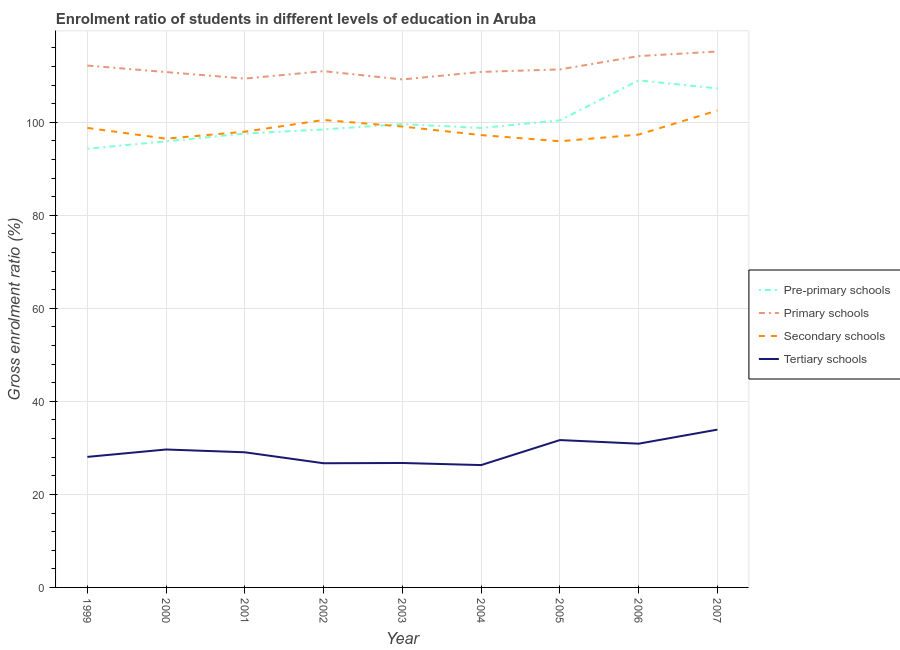How many different coloured lines are there?
Keep it short and to the point. 4. What is the gross enrolment ratio in pre-primary schools in 2001?
Your answer should be compact. 97.58. Across all years, what is the maximum gross enrolment ratio in pre-primary schools?
Your response must be concise. 109.02. Across all years, what is the minimum gross enrolment ratio in tertiary schools?
Keep it short and to the point. 26.3. What is the total gross enrolment ratio in pre-primary schools in the graph?
Keep it short and to the point. 901.43. What is the difference between the gross enrolment ratio in tertiary schools in 2003 and that in 2005?
Ensure brevity in your answer.  -4.93. What is the difference between the gross enrolment ratio in tertiary schools in 2000 and the gross enrolment ratio in primary schools in 2001?
Your answer should be compact. -79.75. What is the average gross enrolment ratio in primary schools per year?
Keep it short and to the point. 111.59. In the year 2000, what is the difference between the gross enrolment ratio in primary schools and gross enrolment ratio in secondary schools?
Offer a terse response. 14.32. In how many years, is the gross enrolment ratio in secondary schools greater than 80 %?
Make the answer very short. 9. What is the ratio of the gross enrolment ratio in secondary schools in 2001 to that in 2005?
Your response must be concise. 1.02. What is the difference between the highest and the second highest gross enrolment ratio in tertiary schools?
Your response must be concise. 2.24. What is the difference between the highest and the lowest gross enrolment ratio in pre-primary schools?
Make the answer very short. 14.69. Is the sum of the gross enrolment ratio in primary schools in 2000 and 2007 greater than the maximum gross enrolment ratio in secondary schools across all years?
Your answer should be compact. Yes. Is it the case that in every year, the sum of the gross enrolment ratio in tertiary schools and gross enrolment ratio in pre-primary schools is greater than the sum of gross enrolment ratio in secondary schools and gross enrolment ratio in primary schools?
Make the answer very short. No. Does the gross enrolment ratio in primary schools monotonically increase over the years?
Your answer should be compact. No. Is the gross enrolment ratio in pre-primary schools strictly greater than the gross enrolment ratio in secondary schools over the years?
Give a very brief answer. No. How are the legend labels stacked?
Make the answer very short. Vertical. What is the title of the graph?
Offer a terse response. Enrolment ratio of students in different levels of education in Aruba. What is the Gross enrolment ratio (%) of Pre-primary schools in 1999?
Give a very brief answer. 94.33. What is the Gross enrolment ratio (%) of Primary schools in 1999?
Provide a succinct answer. 112.2. What is the Gross enrolment ratio (%) in Secondary schools in 1999?
Give a very brief answer. 98.8. What is the Gross enrolment ratio (%) of Tertiary schools in 1999?
Keep it short and to the point. 28.07. What is the Gross enrolment ratio (%) in Pre-primary schools in 2000?
Keep it short and to the point. 95.9. What is the Gross enrolment ratio (%) of Primary schools in 2000?
Your answer should be very brief. 110.8. What is the Gross enrolment ratio (%) of Secondary schools in 2000?
Your answer should be compact. 96.49. What is the Gross enrolment ratio (%) of Tertiary schools in 2000?
Offer a terse response. 29.66. What is the Gross enrolment ratio (%) of Pre-primary schools in 2001?
Provide a short and direct response. 97.58. What is the Gross enrolment ratio (%) in Primary schools in 2001?
Provide a succinct answer. 109.4. What is the Gross enrolment ratio (%) of Secondary schools in 2001?
Keep it short and to the point. 97.99. What is the Gross enrolment ratio (%) in Tertiary schools in 2001?
Provide a succinct answer. 29.06. What is the Gross enrolment ratio (%) of Pre-primary schools in 2002?
Offer a very short reply. 98.47. What is the Gross enrolment ratio (%) of Primary schools in 2002?
Your answer should be very brief. 111. What is the Gross enrolment ratio (%) of Secondary schools in 2002?
Give a very brief answer. 100.51. What is the Gross enrolment ratio (%) of Tertiary schools in 2002?
Provide a short and direct response. 26.7. What is the Gross enrolment ratio (%) of Pre-primary schools in 2003?
Give a very brief answer. 99.62. What is the Gross enrolment ratio (%) in Primary schools in 2003?
Keep it short and to the point. 109.21. What is the Gross enrolment ratio (%) of Secondary schools in 2003?
Offer a very short reply. 99.09. What is the Gross enrolment ratio (%) of Tertiary schools in 2003?
Your answer should be compact. 26.76. What is the Gross enrolment ratio (%) of Pre-primary schools in 2004?
Offer a very short reply. 98.78. What is the Gross enrolment ratio (%) in Primary schools in 2004?
Your answer should be very brief. 110.84. What is the Gross enrolment ratio (%) in Secondary schools in 2004?
Your response must be concise. 97.25. What is the Gross enrolment ratio (%) of Tertiary schools in 2004?
Provide a succinct answer. 26.3. What is the Gross enrolment ratio (%) of Pre-primary schools in 2005?
Ensure brevity in your answer.  100.43. What is the Gross enrolment ratio (%) in Primary schools in 2005?
Ensure brevity in your answer.  111.38. What is the Gross enrolment ratio (%) in Secondary schools in 2005?
Offer a terse response. 95.93. What is the Gross enrolment ratio (%) of Tertiary schools in 2005?
Ensure brevity in your answer.  31.68. What is the Gross enrolment ratio (%) in Pre-primary schools in 2006?
Your answer should be compact. 109.02. What is the Gross enrolment ratio (%) in Primary schools in 2006?
Provide a succinct answer. 114.24. What is the Gross enrolment ratio (%) in Secondary schools in 2006?
Offer a very short reply. 97.36. What is the Gross enrolment ratio (%) in Tertiary schools in 2006?
Give a very brief answer. 30.9. What is the Gross enrolment ratio (%) in Pre-primary schools in 2007?
Give a very brief answer. 107.29. What is the Gross enrolment ratio (%) of Primary schools in 2007?
Offer a terse response. 115.22. What is the Gross enrolment ratio (%) of Secondary schools in 2007?
Offer a very short reply. 102.55. What is the Gross enrolment ratio (%) of Tertiary schools in 2007?
Keep it short and to the point. 33.93. Across all years, what is the maximum Gross enrolment ratio (%) of Pre-primary schools?
Keep it short and to the point. 109.02. Across all years, what is the maximum Gross enrolment ratio (%) of Primary schools?
Your answer should be compact. 115.22. Across all years, what is the maximum Gross enrolment ratio (%) in Secondary schools?
Give a very brief answer. 102.55. Across all years, what is the maximum Gross enrolment ratio (%) of Tertiary schools?
Make the answer very short. 33.93. Across all years, what is the minimum Gross enrolment ratio (%) in Pre-primary schools?
Your answer should be compact. 94.33. Across all years, what is the minimum Gross enrolment ratio (%) in Primary schools?
Your response must be concise. 109.21. Across all years, what is the minimum Gross enrolment ratio (%) of Secondary schools?
Make the answer very short. 95.93. Across all years, what is the minimum Gross enrolment ratio (%) of Tertiary schools?
Provide a succinct answer. 26.3. What is the total Gross enrolment ratio (%) in Pre-primary schools in the graph?
Offer a terse response. 901.43. What is the total Gross enrolment ratio (%) of Primary schools in the graph?
Provide a succinct answer. 1004.29. What is the total Gross enrolment ratio (%) in Secondary schools in the graph?
Give a very brief answer. 885.95. What is the total Gross enrolment ratio (%) in Tertiary schools in the graph?
Your response must be concise. 263.05. What is the difference between the Gross enrolment ratio (%) of Pre-primary schools in 1999 and that in 2000?
Offer a very short reply. -1.57. What is the difference between the Gross enrolment ratio (%) in Primary schools in 1999 and that in 2000?
Provide a short and direct response. 1.4. What is the difference between the Gross enrolment ratio (%) of Secondary schools in 1999 and that in 2000?
Provide a short and direct response. 2.31. What is the difference between the Gross enrolment ratio (%) in Tertiary schools in 1999 and that in 2000?
Your answer should be very brief. -1.59. What is the difference between the Gross enrolment ratio (%) of Pre-primary schools in 1999 and that in 2001?
Your response must be concise. -3.25. What is the difference between the Gross enrolment ratio (%) in Primary schools in 1999 and that in 2001?
Keep it short and to the point. 2.8. What is the difference between the Gross enrolment ratio (%) of Secondary schools in 1999 and that in 2001?
Keep it short and to the point. 0.81. What is the difference between the Gross enrolment ratio (%) of Tertiary schools in 1999 and that in 2001?
Provide a succinct answer. -0.99. What is the difference between the Gross enrolment ratio (%) of Pre-primary schools in 1999 and that in 2002?
Your answer should be compact. -4.14. What is the difference between the Gross enrolment ratio (%) of Primary schools in 1999 and that in 2002?
Keep it short and to the point. 1.2. What is the difference between the Gross enrolment ratio (%) in Secondary schools in 1999 and that in 2002?
Offer a terse response. -1.71. What is the difference between the Gross enrolment ratio (%) in Tertiary schools in 1999 and that in 2002?
Your answer should be very brief. 1.37. What is the difference between the Gross enrolment ratio (%) of Pre-primary schools in 1999 and that in 2003?
Offer a terse response. -5.29. What is the difference between the Gross enrolment ratio (%) of Primary schools in 1999 and that in 2003?
Give a very brief answer. 2.98. What is the difference between the Gross enrolment ratio (%) of Secondary schools in 1999 and that in 2003?
Ensure brevity in your answer.  -0.29. What is the difference between the Gross enrolment ratio (%) in Tertiary schools in 1999 and that in 2003?
Ensure brevity in your answer.  1.31. What is the difference between the Gross enrolment ratio (%) in Pre-primary schools in 1999 and that in 2004?
Offer a terse response. -4.45. What is the difference between the Gross enrolment ratio (%) in Primary schools in 1999 and that in 2004?
Ensure brevity in your answer.  1.36. What is the difference between the Gross enrolment ratio (%) in Secondary schools in 1999 and that in 2004?
Keep it short and to the point. 1.54. What is the difference between the Gross enrolment ratio (%) in Tertiary schools in 1999 and that in 2004?
Offer a very short reply. 1.76. What is the difference between the Gross enrolment ratio (%) of Pre-primary schools in 1999 and that in 2005?
Give a very brief answer. -6.1. What is the difference between the Gross enrolment ratio (%) of Primary schools in 1999 and that in 2005?
Offer a very short reply. 0.82. What is the difference between the Gross enrolment ratio (%) of Secondary schools in 1999 and that in 2005?
Your answer should be compact. 2.87. What is the difference between the Gross enrolment ratio (%) in Tertiary schools in 1999 and that in 2005?
Keep it short and to the point. -3.62. What is the difference between the Gross enrolment ratio (%) of Pre-primary schools in 1999 and that in 2006?
Provide a succinct answer. -14.69. What is the difference between the Gross enrolment ratio (%) of Primary schools in 1999 and that in 2006?
Provide a succinct answer. -2.04. What is the difference between the Gross enrolment ratio (%) in Secondary schools in 1999 and that in 2006?
Keep it short and to the point. 1.44. What is the difference between the Gross enrolment ratio (%) of Tertiary schools in 1999 and that in 2006?
Give a very brief answer. -2.84. What is the difference between the Gross enrolment ratio (%) in Pre-primary schools in 1999 and that in 2007?
Ensure brevity in your answer.  -12.96. What is the difference between the Gross enrolment ratio (%) in Primary schools in 1999 and that in 2007?
Make the answer very short. -3.03. What is the difference between the Gross enrolment ratio (%) of Secondary schools in 1999 and that in 2007?
Provide a succinct answer. -3.75. What is the difference between the Gross enrolment ratio (%) of Tertiary schools in 1999 and that in 2007?
Give a very brief answer. -5.86. What is the difference between the Gross enrolment ratio (%) of Pre-primary schools in 2000 and that in 2001?
Offer a terse response. -1.68. What is the difference between the Gross enrolment ratio (%) of Primary schools in 2000 and that in 2001?
Make the answer very short. 1.4. What is the difference between the Gross enrolment ratio (%) in Secondary schools in 2000 and that in 2001?
Your response must be concise. -1.5. What is the difference between the Gross enrolment ratio (%) in Tertiary schools in 2000 and that in 2001?
Provide a short and direct response. 0.6. What is the difference between the Gross enrolment ratio (%) in Pre-primary schools in 2000 and that in 2002?
Keep it short and to the point. -2.57. What is the difference between the Gross enrolment ratio (%) in Primary schools in 2000 and that in 2002?
Make the answer very short. -0.2. What is the difference between the Gross enrolment ratio (%) of Secondary schools in 2000 and that in 2002?
Your answer should be compact. -4.02. What is the difference between the Gross enrolment ratio (%) in Tertiary schools in 2000 and that in 2002?
Provide a succinct answer. 2.96. What is the difference between the Gross enrolment ratio (%) in Pre-primary schools in 2000 and that in 2003?
Provide a succinct answer. -3.72. What is the difference between the Gross enrolment ratio (%) of Primary schools in 2000 and that in 2003?
Your answer should be very brief. 1.59. What is the difference between the Gross enrolment ratio (%) in Secondary schools in 2000 and that in 2003?
Give a very brief answer. -2.61. What is the difference between the Gross enrolment ratio (%) of Tertiary schools in 2000 and that in 2003?
Your answer should be compact. 2.9. What is the difference between the Gross enrolment ratio (%) of Pre-primary schools in 2000 and that in 2004?
Offer a very short reply. -2.88. What is the difference between the Gross enrolment ratio (%) of Primary schools in 2000 and that in 2004?
Ensure brevity in your answer.  -0.04. What is the difference between the Gross enrolment ratio (%) of Secondary schools in 2000 and that in 2004?
Your answer should be compact. -0.77. What is the difference between the Gross enrolment ratio (%) of Tertiary schools in 2000 and that in 2004?
Ensure brevity in your answer.  3.35. What is the difference between the Gross enrolment ratio (%) in Pre-primary schools in 2000 and that in 2005?
Ensure brevity in your answer.  -4.52. What is the difference between the Gross enrolment ratio (%) in Primary schools in 2000 and that in 2005?
Offer a very short reply. -0.58. What is the difference between the Gross enrolment ratio (%) in Secondary schools in 2000 and that in 2005?
Your answer should be compact. 0.56. What is the difference between the Gross enrolment ratio (%) of Tertiary schools in 2000 and that in 2005?
Offer a terse response. -2.03. What is the difference between the Gross enrolment ratio (%) in Pre-primary schools in 2000 and that in 2006?
Your answer should be compact. -13.12. What is the difference between the Gross enrolment ratio (%) of Primary schools in 2000 and that in 2006?
Offer a very short reply. -3.44. What is the difference between the Gross enrolment ratio (%) of Secondary schools in 2000 and that in 2006?
Give a very brief answer. -0.87. What is the difference between the Gross enrolment ratio (%) of Tertiary schools in 2000 and that in 2006?
Give a very brief answer. -1.25. What is the difference between the Gross enrolment ratio (%) of Pre-primary schools in 2000 and that in 2007?
Your answer should be compact. -11.39. What is the difference between the Gross enrolment ratio (%) in Primary schools in 2000 and that in 2007?
Offer a terse response. -4.42. What is the difference between the Gross enrolment ratio (%) of Secondary schools in 2000 and that in 2007?
Offer a terse response. -6.06. What is the difference between the Gross enrolment ratio (%) of Tertiary schools in 2000 and that in 2007?
Your answer should be compact. -4.27. What is the difference between the Gross enrolment ratio (%) in Pre-primary schools in 2001 and that in 2002?
Your response must be concise. -0.89. What is the difference between the Gross enrolment ratio (%) of Primary schools in 2001 and that in 2002?
Make the answer very short. -1.6. What is the difference between the Gross enrolment ratio (%) of Secondary schools in 2001 and that in 2002?
Your answer should be compact. -2.52. What is the difference between the Gross enrolment ratio (%) in Tertiary schools in 2001 and that in 2002?
Your answer should be very brief. 2.36. What is the difference between the Gross enrolment ratio (%) of Pre-primary schools in 2001 and that in 2003?
Give a very brief answer. -2.04. What is the difference between the Gross enrolment ratio (%) of Primary schools in 2001 and that in 2003?
Provide a short and direct response. 0.19. What is the difference between the Gross enrolment ratio (%) in Secondary schools in 2001 and that in 2003?
Give a very brief answer. -1.1. What is the difference between the Gross enrolment ratio (%) of Tertiary schools in 2001 and that in 2003?
Provide a short and direct response. 2.3. What is the difference between the Gross enrolment ratio (%) in Pre-primary schools in 2001 and that in 2004?
Offer a terse response. -1.2. What is the difference between the Gross enrolment ratio (%) of Primary schools in 2001 and that in 2004?
Provide a short and direct response. -1.44. What is the difference between the Gross enrolment ratio (%) in Secondary schools in 2001 and that in 2004?
Provide a succinct answer. 0.74. What is the difference between the Gross enrolment ratio (%) in Tertiary schools in 2001 and that in 2004?
Your response must be concise. 2.75. What is the difference between the Gross enrolment ratio (%) in Pre-primary schools in 2001 and that in 2005?
Offer a terse response. -2.84. What is the difference between the Gross enrolment ratio (%) of Primary schools in 2001 and that in 2005?
Provide a succinct answer. -1.97. What is the difference between the Gross enrolment ratio (%) in Secondary schools in 2001 and that in 2005?
Provide a succinct answer. 2.06. What is the difference between the Gross enrolment ratio (%) in Tertiary schools in 2001 and that in 2005?
Make the answer very short. -2.63. What is the difference between the Gross enrolment ratio (%) in Pre-primary schools in 2001 and that in 2006?
Make the answer very short. -11.44. What is the difference between the Gross enrolment ratio (%) of Primary schools in 2001 and that in 2006?
Your response must be concise. -4.84. What is the difference between the Gross enrolment ratio (%) of Secondary schools in 2001 and that in 2006?
Your response must be concise. 0.63. What is the difference between the Gross enrolment ratio (%) in Tertiary schools in 2001 and that in 2006?
Your answer should be very brief. -1.85. What is the difference between the Gross enrolment ratio (%) in Pre-primary schools in 2001 and that in 2007?
Your answer should be very brief. -9.71. What is the difference between the Gross enrolment ratio (%) in Primary schools in 2001 and that in 2007?
Your answer should be compact. -5.82. What is the difference between the Gross enrolment ratio (%) of Secondary schools in 2001 and that in 2007?
Provide a short and direct response. -4.56. What is the difference between the Gross enrolment ratio (%) in Tertiary schools in 2001 and that in 2007?
Your response must be concise. -4.87. What is the difference between the Gross enrolment ratio (%) in Pre-primary schools in 2002 and that in 2003?
Your answer should be compact. -1.15. What is the difference between the Gross enrolment ratio (%) of Primary schools in 2002 and that in 2003?
Offer a very short reply. 1.78. What is the difference between the Gross enrolment ratio (%) in Secondary schools in 2002 and that in 2003?
Your answer should be compact. 1.41. What is the difference between the Gross enrolment ratio (%) in Tertiary schools in 2002 and that in 2003?
Your response must be concise. -0.06. What is the difference between the Gross enrolment ratio (%) in Pre-primary schools in 2002 and that in 2004?
Give a very brief answer. -0.31. What is the difference between the Gross enrolment ratio (%) in Primary schools in 2002 and that in 2004?
Keep it short and to the point. 0.16. What is the difference between the Gross enrolment ratio (%) of Secondary schools in 2002 and that in 2004?
Keep it short and to the point. 3.25. What is the difference between the Gross enrolment ratio (%) in Tertiary schools in 2002 and that in 2004?
Ensure brevity in your answer.  0.39. What is the difference between the Gross enrolment ratio (%) in Pre-primary schools in 2002 and that in 2005?
Give a very brief answer. -1.96. What is the difference between the Gross enrolment ratio (%) of Primary schools in 2002 and that in 2005?
Your response must be concise. -0.38. What is the difference between the Gross enrolment ratio (%) of Secondary schools in 2002 and that in 2005?
Offer a terse response. 4.58. What is the difference between the Gross enrolment ratio (%) in Tertiary schools in 2002 and that in 2005?
Ensure brevity in your answer.  -4.99. What is the difference between the Gross enrolment ratio (%) of Pre-primary schools in 2002 and that in 2006?
Provide a succinct answer. -10.55. What is the difference between the Gross enrolment ratio (%) in Primary schools in 2002 and that in 2006?
Ensure brevity in your answer.  -3.24. What is the difference between the Gross enrolment ratio (%) of Secondary schools in 2002 and that in 2006?
Keep it short and to the point. 3.15. What is the difference between the Gross enrolment ratio (%) of Tertiary schools in 2002 and that in 2006?
Your answer should be compact. -4.21. What is the difference between the Gross enrolment ratio (%) in Pre-primary schools in 2002 and that in 2007?
Offer a very short reply. -8.82. What is the difference between the Gross enrolment ratio (%) in Primary schools in 2002 and that in 2007?
Ensure brevity in your answer.  -4.23. What is the difference between the Gross enrolment ratio (%) of Secondary schools in 2002 and that in 2007?
Your response must be concise. -2.04. What is the difference between the Gross enrolment ratio (%) of Tertiary schools in 2002 and that in 2007?
Your answer should be compact. -7.23. What is the difference between the Gross enrolment ratio (%) of Pre-primary schools in 2003 and that in 2004?
Provide a short and direct response. 0.84. What is the difference between the Gross enrolment ratio (%) in Primary schools in 2003 and that in 2004?
Your answer should be very brief. -1.62. What is the difference between the Gross enrolment ratio (%) in Secondary schools in 2003 and that in 2004?
Keep it short and to the point. 1.84. What is the difference between the Gross enrolment ratio (%) of Tertiary schools in 2003 and that in 2004?
Provide a short and direct response. 0.45. What is the difference between the Gross enrolment ratio (%) of Pre-primary schools in 2003 and that in 2005?
Offer a terse response. -0.8. What is the difference between the Gross enrolment ratio (%) of Primary schools in 2003 and that in 2005?
Ensure brevity in your answer.  -2.16. What is the difference between the Gross enrolment ratio (%) of Secondary schools in 2003 and that in 2005?
Offer a terse response. 3.16. What is the difference between the Gross enrolment ratio (%) in Tertiary schools in 2003 and that in 2005?
Your response must be concise. -4.93. What is the difference between the Gross enrolment ratio (%) of Pre-primary schools in 2003 and that in 2006?
Provide a succinct answer. -9.4. What is the difference between the Gross enrolment ratio (%) in Primary schools in 2003 and that in 2006?
Your response must be concise. -5.02. What is the difference between the Gross enrolment ratio (%) in Secondary schools in 2003 and that in 2006?
Make the answer very short. 1.73. What is the difference between the Gross enrolment ratio (%) of Tertiary schools in 2003 and that in 2006?
Ensure brevity in your answer.  -4.15. What is the difference between the Gross enrolment ratio (%) of Pre-primary schools in 2003 and that in 2007?
Your answer should be very brief. -7.67. What is the difference between the Gross enrolment ratio (%) of Primary schools in 2003 and that in 2007?
Your response must be concise. -6.01. What is the difference between the Gross enrolment ratio (%) in Secondary schools in 2003 and that in 2007?
Ensure brevity in your answer.  -3.46. What is the difference between the Gross enrolment ratio (%) of Tertiary schools in 2003 and that in 2007?
Your answer should be very brief. -7.17. What is the difference between the Gross enrolment ratio (%) of Pre-primary schools in 2004 and that in 2005?
Provide a succinct answer. -1.65. What is the difference between the Gross enrolment ratio (%) in Primary schools in 2004 and that in 2005?
Ensure brevity in your answer.  -0.54. What is the difference between the Gross enrolment ratio (%) in Secondary schools in 2004 and that in 2005?
Make the answer very short. 1.32. What is the difference between the Gross enrolment ratio (%) in Tertiary schools in 2004 and that in 2005?
Provide a short and direct response. -5.38. What is the difference between the Gross enrolment ratio (%) of Pre-primary schools in 2004 and that in 2006?
Offer a very short reply. -10.24. What is the difference between the Gross enrolment ratio (%) of Primary schools in 2004 and that in 2006?
Ensure brevity in your answer.  -3.4. What is the difference between the Gross enrolment ratio (%) of Secondary schools in 2004 and that in 2006?
Your response must be concise. -0.1. What is the difference between the Gross enrolment ratio (%) in Tertiary schools in 2004 and that in 2006?
Provide a succinct answer. -4.6. What is the difference between the Gross enrolment ratio (%) of Pre-primary schools in 2004 and that in 2007?
Give a very brief answer. -8.51. What is the difference between the Gross enrolment ratio (%) of Primary schools in 2004 and that in 2007?
Offer a terse response. -4.39. What is the difference between the Gross enrolment ratio (%) of Secondary schools in 2004 and that in 2007?
Your answer should be very brief. -5.29. What is the difference between the Gross enrolment ratio (%) in Tertiary schools in 2004 and that in 2007?
Your response must be concise. -7.62. What is the difference between the Gross enrolment ratio (%) of Pre-primary schools in 2005 and that in 2006?
Give a very brief answer. -8.59. What is the difference between the Gross enrolment ratio (%) in Primary schools in 2005 and that in 2006?
Your answer should be compact. -2.86. What is the difference between the Gross enrolment ratio (%) of Secondary schools in 2005 and that in 2006?
Your answer should be compact. -1.43. What is the difference between the Gross enrolment ratio (%) of Tertiary schools in 2005 and that in 2006?
Provide a succinct answer. 0.78. What is the difference between the Gross enrolment ratio (%) in Pre-primary schools in 2005 and that in 2007?
Offer a very short reply. -6.86. What is the difference between the Gross enrolment ratio (%) of Primary schools in 2005 and that in 2007?
Offer a terse response. -3.85. What is the difference between the Gross enrolment ratio (%) in Secondary schools in 2005 and that in 2007?
Ensure brevity in your answer.  -6.62. What is the difference between the Gross enrolment ratio (%) of Tertiary schools in 2005 and that in 2007?
Provide a succinct answer. -2.24. What is the difference between the Gross enrolment ratio (%) in Pre-primary schools in 2006 and that in 2007?
Your answer should be very brief. 1.73. What is the difference between the Gross enrolment ratio (%) in Primary schools in 2006 and that in 2007?
Provide a short and direct response. -0.99. What is the difference between the Gross enrolment ratio (%) of Secondary schools in 2006 and that in 2007?
Keep it short and to the point. -5.19. What is the difference between the Gross enrolment ratio (%) of Tertiary schools in 2006 and that in 2007?
Keep it short and to the point. -3.02. What is the difference between the Gross enrolment ratio (%) of Pre-primary schools in 1999 and the Gross enrolment ratio (%) of Primary schools in 2000?
Provide a short and direct response. -16.47. What is the difference between the Gross enrolment ratio (%) of Pre-primary schools in 1999 and the Gross enrolment ratio (%) of Secondary schools in 2000?
Give a very brief answer. -2.16. What is the difference between the Gross enrolment ratio (%) in Pre-primary schools in 1999 and the Gross enrolment ratio (%) in Tertiary schools in 2000?
Give a very brief answer. 64.67. What is the difference between the Gross enrolment ratio (%) of Primary schools in 1999 and the Gross enrolment ratio (%) of Secondary schools in 2000?
Make the answer very short. 15.71. What is the difference between the Gross enrolment ratio (%) of Primary schools in 1999 and the Gross enrolment ratio (%) of Tertiary schools in 2000?
Give a very brief answer. 82.54. What is the difference between the Gross enrolment ratio (%) in Secondary schools in 1999 and the Gross enrolment ratio (%) in Tertiary schools in 2000?
Make the answer very short. 69.14. What is the difference between the Gross enrolment ratio (%) of Pre-primary schools in 1999 and the Gross enrolment ratio (%) of Primary schools in 2001?
Give a very brief answer. -15.07. What is the difference between the Gross enrolment ratio (%) of Pre-primary schools in 1999 and the Gross enrolment ratio (%) of Secondary schools in 2001?
Your answer should be compact. -3.66. What is the difference between the Gross enrolment ratio (%) in Pre-primary schools in 1999 and the Gross enrolment ratio (%) in Tertiary schools in 2001?
Provide a short and direct response. 65.27. What is the difference between the Gross enrolment ratio (%) of Primary schools in 1999 and the Gross enrolment ratio (%) of Secondary schools in 2001?
Ensure brevity in your answer.  14.21. What is the difference between the Gross enrolment ratio (%) in Primary schools in 1999 and the Gross enrolment ratio (%) in Tertiary schools in 2001?
Give a very brief answer. 83.14. What is the difference between the Gross enrolment ratio (%) in Secondary schools in 1999 and the Gross enrolment ratio (%) in Tertiary schools in 2001?
Your answer should be very brief. 69.74. What is the difference between the Gross enrolment ratio (%) of Pre-primary schools in 1999 and the Gross enrolment ratio (%) of Primary schools in 2002?
Your answer should be compact. -16.67. What is the difference between the Gross enrolment ratio (%) of Pre-primary schools in 1999 and the Gross enrolment ratio (%) of Secondary schools in 2002?
Offer a terse response. -6.18. What is the difference between the Gross enrolment ratio (%) in Pre-primary schools in 1999 and the Gross enrolment ratio (%) in Tertiary schools in 2002?
Provide a succinct answer. 67.63. What is the difference between the Gross enrolment ratio (%) in Primary schools in 1999 and the Gross enrolment ratio (%) in Secondary schools in 2002?
Give a very brief answer. 11.69. What is the difference between the Gross enrolment ratio (%) in Primary schools in 1999 and the Gross enrolment ratio (%) in Tertiary schools in 2002?
Provide a succinct answer. 85.5. What is the difference between the Gross enrolment ratio (%) in Secondary schools in 1999 and the Gross enrolment ratio (%) in Tertiary schools in 2002?
Keep it short and to the point. 72.1. What is the difference between the Gross enrolment ratio (%) of Pre-primary schools in 1999 and the Gross enrolment ratio (%) of Primary schools in 2003?
Your answer should be compact. -14.88. What is the difference between the Gross enrolment ratio (%) in Pre-primary schools in 1999 and the Gross enrolment ratio (%) in Secondary schools in 2003?
Your answer should be very brief. -4.76. What is the difference between the Gross enrolment ratio (%) in Pre-primary schools in 1999 and the Gross enrolment ratio (%) in Tertiary schools in 2003?
Ensure brevity in your answer.  67.57. What is the difference between the Gross enrolment ratio (%) of Primary schools in 1999 and the Gross enrolment ratio (%) of Secondary schools in 2003?
Offer a terse response. 13.11. What is the difference between the Gross enrolment ratio (%) in Primary schools in 1999 and the Gross enrolment ratio (%) in Tertiary schools in 2003?
Make the answer very short. 85.44. What is the difference between the Gross enrolment ratio (%) of Secondary schools in 1999 and the Gross enrolment ratio (%) of Tertiary schools in 2003?
Offer a very short reply. 72.04. What is the difference between the Gross enrolment ratio (%) of Pre-primary schools in 1999 and the Gross enrolment ratio (%) of Primary schools in 2004?
Your response must be concise. -16.51. What is the difference between the Gross enrolment ratio (%) in Pre-primary schools in 1999 and the Gross enrolment ratio (%) in Secondary schools in 2004?
Make the answer very short. -2.92. What is the difference between the Gross enrolment ratio (%) of Pre-primary schools in 1999 and the Gross enrolment ratio (%) of Tertiary schools in 2004?
Offer a very short reply. 68.03. What is the difference between the Gross enrolment ratio (%) of Primary schools in 1999 and the Gross enrolment ratio (%) of Secondary schools in 2004?
Keep it short and to the point. 14.95. What is the difference between the Gross enrolment ratio (%) of Primary schools in 1999 and the Gross enrolment ratio (%) of Tertiary schools in 2004?
Your response must be concise. 85.89. What is the difference between the Gross enrolment ratio (%) of Secondary schools in 1999 and the Gross enrolment ratio (%) of Tertiary schools in 2004?
Make the answer very short. 72.49. What is the difference between the Gross enrolment ratio (%) of Pre-primary schools in 1999 and the Gross enrolment ratio (%) of Primary schools in 2005?
Give a very brief answer. -17.05. What is the difference between the Gross enrolment ratio (%) of Pre-primary schools in 1999 and the Gross enrolment ratio (%) of Secondary schools in 2005?
Provide a short and direct response. -1.6. What is the difference between the Gross enrolment ratio (%) of Pre-primary schools in 1999 and the Gross enrolment ratio (%) of Tertiary schools in 2005?
Provide a short and direct response. 62.65. What is the difference between the Gross enrolment ratio (%) in Primary schools in 1999 and the Gross enrolment ratio (%) in Secondary schools in 2005?
Offer a terse response. 16.27. What is the difference between the Gross enrolment ratio (%) of Primary schools in 1999 and the Gross enrolment ratio (%) of Tertiary schools in 2005?
Keep it short and to the point. 80.52. What is the difference between the Gross enrolment ratio (%) in Secondary schools in 1999 and the Gross enrolment ratio (%) in Tertiary schools in 2005?
Give a very brief answer. 67.11. What is the difference between the Gross enrolment ratio (%) in Pre-primary schools in 1999 and the Gross enrolment ratio (%) in Primary schools in 2006?
Offer a very short reply. -19.91. What is the difference between the Gross enrolment ratio (%) of Pre-primary schools in 1999 and the Gross enrolment ratio (%) of Secondary schools in 2006?
Give a very brief answer. -3.03. What is the difference between the Gross enrolment ratio (%) of Pre-primary schools in 1999 and the Gross enrolment ratio (%) of Tertiary schools in 2006?
Ensure brevity in your answer.  63.43. What is the difference between the Gross enrolment ratio (%) in Primary schools in 1999 and the Gross enrolment ratio (%) in Secondary schools in 2006?
Keep it short and to the point. 14.84. What is the difference between the Gross enrolment ratio (%) in Primary schools in 1999 and the Gross enrolment ratio (%) in Tertiary schools in 2006?
Your response must be concise. 81.3. What is the difference between the Gross enrolment ratio (%) in Secondary schools in 1999 and the Gross enrolment ratio (%) in Tertiary schools in 2006?
Make the answer very short. 67.89. What is the difference between the Gross enrolment ratio (%) in Pre-primary schools in 1999 and the Gross enrolment ratio (%) in Primary schools in 2007?
Your answer should be compact. -20.89. What is the difference between the Gross enrolment ratio (%) in Pre-primary schools in 1999 and the Gross enrolment ratio (%) in Secondary schools in 2007?
Make the answer very short. -8.22. What is the difference between the Gross enrolment ratio (%) of Pre-primary schools in 1999 and the Gross enrolment ratio (%) of Tertiary schools in 2007?
Your answer should be very brief. 60.4. What is the difference between the Gross enrolment ratio (%) of Primary schools in 1999 and the Gross enrolment ratio (%) of Secondary schools in 2007?
Provide a short and direct response. 9.65. What is the difference between the Gross enrolment ratio (%) of Primary schools in 1999 and the Gross enrolment ratio (%) of Tertiary schools in 2007?
Offer a very short reply. 78.27. What is the difference between the Gross enrolment ratio (%) of Secondary schools in 1999 and the Gross enrolment ratio (%) of Tertiary schools in 2007?
Keep it short and to the point. 64.87. What is the difference between the Gross enrolment ratio (%) of Pre-primary schools in 2000 and the Gross enrolment ratio (%) of Primary schools in 2001?
Offer a terse response. -13.5. What is the difference between the Gross enrolment ratio (%) of Pre-primary schools in 2000 and the Gross enrolment ratio (%) of Secondary schools in 2001?
Ensure brevity in your answer.  -2.08. What is the difference between the Gross enrolment ratio (%) in Pre-primary schools in 2000 and the Gross enrolment ratio (%) in Tertiary schools in 2001?
Keep it short and to the point. 66.85. What is the difference between the Gross enrolment ratio (%) in Primary schools in 2000 and the Gross enrolment ratio (%) in Secondary schools in 2001?
Give a very brief answer. 12.81. What is the difference between the Gross enrolment ratio (%) in Primary schools in 2000 and the Gross enrolment ratio (%) in Tertiary schools in 2001?
Your answer should be compact. 81.75. What is the difference between the Gross enrolment ratio (%) in Secondary schools in 2000 and the Gross enrolment ratio (%) in Tertiary schools in 2001?
Make the answer very short. 67.43. What is the difference between the Gross enrolment ratio (%) of Pre-primary schools in 2000 and the Gross enrolment ratio (%) of Primary schools in 2002?
Your answer should be very brief. -15.1. What is the difference between the Gross enrolment ratio (%) in Pre-primary schools in 2000 and the Gross enrolment ratio (%) in Secondary schools in 2002?
Offer a very short reply. -4.6. What is the difference between the Gross enrolment ratio (%) in Pre-primary schools in 2000 and the Gross enrolment ratio (%) in Tertiary schools in 2002?
Make the answer very short. 69.21. What is the difference between the Gross enrolment ratio (%) in Primary schools in 2000 and the Gross enrolment ratio (%) in Secondary schools in 2002?
Make the answer very short. 10.3. What is the difference between the Gross enrolment ratio (%) in Primary schools in 2000 and the Gross enrolment ratio (%) in Tertiary schools in 2002?
Ensure brevity in your answer.  84.1. What is the difference between the Gross enrolment ratio (%) of Secondary schools in 2000 and the Gross enrolment ratio (%) of Tertiary schools in 2002?
Your answer should be compact. 69.79. What is the difference between the Gross enrolment ratio (%) in Pre-primary schools in 2000 and the Gross enrolment ratio (%) in Primary schools in 2003?
Give a very brief answer. -13.31. What is the difference between the Gross enrolment ratio (%) of Pre-primary schools in 2000 and the Gross enrolment ratio (%) of Secondary schools in 2003?
Offer a very short reply. -3.19. What is the difference between the Gross enrolment ratio (%) of Pre-primary schools in 2000 and the Gross enrolment ratio (%) of Tertiary schools in 2003?
Give a very brief answer. 69.15. What is the difference between the Gross enrolment ratio (%) of Primary schools in 2000 and the Gross enrolment ratio (%) of Secondary schools in 2003?
Ensure brevity in your answer.  11.71. What is the difference between the Gross enrolment ratio (%) of Primary schools in 2000 and the Gross enrolment ratio (%) of Tertiary schools in 2003?
Keep it short and to the point. 84.05. What is the difference between the Gross enrolment ratio (%) in Secondary schools in 2000 and the Gross enrolment ratio (%) in Tertiary schools in 2003?
Keep it short and to the point. 69.73. What is the difference between the Gross enrolment ratio (%) in Pre-primary schools in 2000 and the Gross enrolment ratio (%) in Primary schools in 2004?
Provide a short and direct response. -14.94. What is the difference between the Gross enrolment ratio (%) in Pre-primary schools in 2000 and the Gross enrolment ratio (%) in Secondary schools in 2004?
Your answer should be very brief. -1.35. What is the difference between the Gross enrolment ratio (%) in Pre-primary schools in 2000 and the Gross enrolment ratio (%) in Tertiary schools in 2004?
Ensure brevity in your answer.  69.6. What is the difference between the Gross enrolment ratio (%) in Primary schools in 2000 and the Gross enrolment ratio (%) in Secondary schools in 2004?
Keep it short and to the point. 13.55. What is the difference between the Gross enrolment ratio (%) in Primary schools in 2000 and the Gross enrolment ratio (%) in Tertiary schools in 2004?
Give a very brief answer. 84.5. What is the difference between the Gross enrolment ratio (%) of Secondary schools in 2000 and the Gross enrolment ratio (%) of Tertiary schools in 2004?
Provide a succinct answer. 70.18. What is the difference between the Gross enrolment ratio (%) in Pre-primary schools in 2000 and the Gross enrolment ratio (%) in Primary schools in 2005?
Provide a short and direct response. -15.47. What is the difference between the Gross enrolment ratio (%) in Pre-primary schools in 2000 and the Gross enrolment ratio (%) in Secondary schools in 2005?
Offer a terse response. -0.03. What is the difference between the Gross enrolment ratio (%) of Pre-primary schools in 2000 and the Gross enrolment ratio (%) of Tertiary schools in 2005?
Give a very brief answer. 64.22. What is the difference between the Gross enrolment ratio (%) of Primary schools in 2000 and the Gross enrolment ratio (%) of Secondary schools in 2005?
Provide a short and direct response. 14.87. What is the difference between the Gross enrolment ratio (%) of Primary schools in 2000 and the Gross enrolment ratio (%) of Tertiary schools in 2005?
Make the answer very short. 79.12. What is the difference between the Gross enrolment ratio (%) in Secondary schools in 2000 and the Gross enrolment ratio (%) in Tertiary schools in 2005?
Your response must be concise. 64.8. What is the difference between the Gross enrolment ratio (%) of Pre-primary schools in 2000 and the Gross enrolment ratio (%) of Primary schools in 2006?
Provide a succinct answer. -18.34. What is the difference between the Gross enrolment ratio (%) in Pre-primary schools in 2000 and the Gross enrolment ratio (%) in Secondary schools in 2006?
Keep it short and to the point. -1.45. What is the difference between the Gross enrolment ratio (%) of Pre-primary schools in 2000 and the Gross enrolment ratio (%) of Tertiary schools in 2006?
Provide a short and direct response. 65. What is the difference between the Gross enrolment ratio (%) in Primary schools in 2000 and the Gross enrolment ratio (%) in Secondary schools in 2006?
Keep it short and to the point. 13.45. What is the difference between the Gross enrolment ratio (%) of Primary schools in 2000 and the Gross enrolment ratio (%) of Tertiary schools in 2006?
Give a very brief answer. 79.9. What is the difference between the Gross enrolment ratio (%) in Secondary schools in 2000 and the Gross enrolment ratio (%) in Tertiary schools in 2006?
Offer a very short reply. 65.58. What is the difference between the Gross enrolment ratio (%) in Pre-primary schools in 2000 and the Gross enrolment ratio (%) in Primary schools in 2007?
Your answer should be very brief. -19.32. What is the difference between the Gross enrolment ratio (%) in Pre-primary schools in 2000 and the Gross enrolment ratio (%) in Secondary schools in 2007?
Give a very brief answer. -6.64. What is the difference between the Gross enrolment ratio (%) of Pre-primary schools in 2000 and the Gross enrolment ratio (%) of Tertiary schools in 2007?
Offer a very short reply. 61.98. What is the difference between the Gross enrolment ratio (%) in Primary schools in 2000 and the Gross enrolment ratio (%) in Secondary schools in 2007?
Make the answer very short. 8.26. What is the difference between the Gross enrolment ratio (%) of Primary schools in 2000 and the Gross enrolment ratio (%) of Tertiary schools in 2007?
Your answer should be very brief. 76.88. What is the difference between the Gross enrolment ratio (%) in Secondary schools in 2000 and the Gross enrolment ratio (%) in Tertiary schools in 2007?
Make the answer very short. 62.56. What is the difference between the Gross enrolment ratio (%) of Pre-primary schools in 2001 and the Gross enrolment ratio (%) of Primary schools in 2002?
Keep it short and to the point. -13.41. What is the difference between the Gross enrolment ratio (%) of Pre-primary schools in 2001 and the Gross enrolment ratio (%) of Secondary schools in 2002?
Provide a succinct answer. -2.92. What is the difference between the Gross enrolment ratio (%) of Pre-primary schools in 2001 and the Gross enrolment ratio (%) of Tertiary schools in 2002?
Your answer should be very brief. 70.89. What is the difference between the Gross enrolment ratio (%) of Primary schools in 2001 and the Gross enrolment ratio (%) of Secondary schools in 2002?
Provide a succinct answer. 8.9. What is the difference between the Gross enrolment ratio (%) in Primary schools in 2001 and the Gross enrolment ratio (%) in Tertiary schools in 2002?
Offer a terse response. 82.7. What is the difference between the Gross enrolment ratio (%) of Secondary schools in 2001 and the Gross enrolment ratio (%) of Tertiary schools in 2002?
Your response must be concise. 71.29. What is the difference between the Gross enrolment ratio (%) of Pre-primary schools in 2001 and the Gross enrolment ratio (%) of Primary schools in 2003?
Keep it short and to the point. -11.63. What is the difference between the Gross enrolment ratio (%) of Pre-primary schools in 2001 and the Gross enrolment ratio (%) of Secondary schools in 2003?
Provide a succinct answer. -1.51. What is the difference between the Gross enrolment ratio (%) of Pre-primary schools in 2001 and the Gross enrolment ratio (%) of Tertiary schools in 2003?
Offer a terse response. 70.83. What is the difference between the Gross enrolment ratio (%) in Primary schools in 2001 and the Gross enrolment ratio (%) in Secondary schools in 2003?
Give a very brief answer. 10.31. What is the difference between the Gross enrolment ratio (%) in Primary schools in 2001 and the Gross enrolment ratio (%) in Tertiary schools in 2003?
Give a very brief answer. 82.65. What is the difference between the Gross enrolment ratio (%) in Secondary schools in 2001 and the Gross enrolment ratio (%) in Tertiary schools in 2003?
Offer a terse response. 71.23. What is the difference between the Gross enrolment ratio (%) of Pre-primary schools in 2001 and the Gross enrolment ratio (%) of Primary schools in 2004?
Provide a succinct answer. -13.26. What is the difference between the Gross enrolment ratio (%) of Pre-primary schools in 2001 and the Gross enrolment ratio (%) of Secondary schools in 2004?
Offer a terse response. 0.33. What is the difference between the Gross enrolment ratio (%) of Pre-primary schools in 2001 and the Gross enrolment ratio (%) of Tertiary schools in 2004?
Offer a terse response. 71.28. What is the difference between the Gross enrolment ratio (%) of Primary schools in 2001 and the Gross enrolment ratio (%) of Secondary schools in 2004?
Your answer should be compact. 12.15. What is the difference between the Gross enrolment ratio (%) of Primary schools in 2001 and the Gross enrolment ratio (%) of Tertiary schools in 2004?
Keep it short and to the point. 83.1. What is the difference between the Gross enrolment ratio (%) of Secondary schools in 2001 and the Gross enrolment ratio (%) of Tertiary schools in 2004?
Keep it short and to the point. 71.68. What is the difference between the Gross enrolment ratio (%) in Pre-primary schools in 2001 and the Gross enrolment ratio (%) in Primary schools in 2005?
Your answer should be compact. -13.79. What is the difference between the Gross enrolment ratio (%) of Pre-primary schools in 2001 and the Gross enrolment ratio (%) of Secondary schools in 2005?
Offer a very short reply. 1.65. What is the difference between the Gross enrolment ratio (%) in Pre-primary schools in 2001 and the Gross enrolment ratio (%) in Tertiary schools in 2005?
Provide a short and direct response. 65.9. What is the difference between the Gross enrolment ratio (%) of Primary schools in 2001 and the Gross enrolment ratio (%) of Secondary schools in 2005?
Your answer should be very brief. 13.47. What is the difference between the Gross enrolment ratio (%) of Primary schools in 2001 and the Gross enrolment ratio (%) of Tertiary schools in 2005?
Offer a very short reply. 77.72. What is the difference between the Gross enrolment ratio (%) in Secondary schools in 2001 and the Gross enrolment ratio (%) in Tertiary schools in 2005?
Make the answer very short. 66.3. What is the difference between the Gross enrolment ratio (%) in Pre-primary schools in 2001 and the Gross enrolment ratio (%) in Primary schools in 2006?
Offer a very short reply. -16.66. What is the difference between the Gross enrolment ratio (%) in Pre-primary schools in 2001 and the Gross enrolment ratio (%) in Secondary schools in 2006?
Offer a terse response. 0.23. What is the difference between the Gross enrolment ratio (%) of Pre-primary schools in 2001 and the Gross enrolment ratio (%) of Tertiary schools in 2006?
Keep it short and to the point. 66.68. What is the difference between the Gross enrolment ratio (%) in Primary schools in 2001 and the Gross enrolment ratio (%) in Secondary schools in 2006?
Your response must be concise. 12.05. What is the difference between the Gross enrolment ratio (%) of Primary schools in 2001 and the Gross enrolment ratio (%) of Tertiary schools in 2006?
Offer a very short reply. 78.5. What is the difference between the Gross enrolment ratio (%) in Secondary schools in 2001 and the Gross enrolment ratio (%) in Tertiary schools in 2006?
Make the answer very short. 67.08. What is the difference between the Gross enrolment ratio (%) in Pre-primary schools in 2001 and the Gross enrolment ratio (%) in Primary schools in 2007?
Make the answer very short. -17.64. What is the difference between the Gross enrolment ratio (%) of Pre-primary schools in 2001 and the Gross enrolment ratio (%) of Secondary schools in 2007?
Give a very brief answer. -4.96. What is the difference between the Gross enrolment ratio (%) in Pre-primary schools in 2001 and the Gross enrolment ratio (%) in Tertiary schools in 2007?
Provide a succinct answer. 63.66. What is the difference between the Gross enrolment ratio (%) in Primary schools in 2001 and the Gross enrolment ratio (%) in Secondary schools in 2007?
Give a very brief answer. 6.86. What is the difference between the Gross enrolment ratio (%) in Primary schools in 2001 and the Gross enrolment ratio (%) in Tertiary schools in 2007?
Offer a very short reply. 75.48. What is the difference between the Gross enrolment ratio (%) in Secondary schools in 2001 and the Gross enrolment ratio (%) in Tertiary schools in 2007?
Offer a very short reply. 64.06. What is the difference between the Gross enrolment ratio (%) in Pre-primary schools in 2002 and the Gross enrolment ratio (%) in Primary schools in 2003?
Give a very brief answer. -10.74. What is the difference between the Gross enrolment ratio (%) in Pre-primary schools in 2002 and the Gross enrolment ratio (%) in Secondary schools in 2003?
Your answer should be very brief. -0.62. What is the difference between the Gross enrolment ratio (%) in Pre-primary schools in 2002 and the Gross enrolment ratio (%) in Tertiary schools in 2003?
Your answer should be very brief. 71.71. What is the difference between the Gross enrolment ratio (%) in Primary schools in 2002 and the Gross enrolment ratio (%) in Secondary schools in 2003?
Ensure brevity in your answer.  11.91. What is the difference between the Gross enrolment ratio (%) in Primary schools in 2002 and the Gross enrolment ratio (%) in Tertiary schools in 2003?
Offer a terse response. 84.24. What is the difference between the Gross enrolment ratio (%) of Secondary schools in 2002 and the Gross enrolment ratio (%) of Tertiary schools in 2003?
Ensure brevity in your answer.  73.75. What is the difference between the Gross enrolment ratio (%) of Pre-primary schools in 2002 and the Gross enrolment ratio (%) of Primary schools in 2004?
Your response must be concise. -12.37. What is the difference between the Gross enrolment ratio (%) in Pre-primary schools in 2002 and the Gross enrolment ratio (%) in Secondary schools in 2004?
Ensure brevity in your answer.  1.22. What is the difference between the Gross enrolment ratio (%) in Pre-primary schools in 2002 and the Gross enrolment ratio (%) in Tertiary schools in 2004?
Offer a terse response. 72.17. What is the difference between the Gross enrolment ratio (%) in Primary schools in 2002 and the Gross enrolment ratio (%) in Secondary schools in 2004?
Your answer should be very brief. 13.75. What is the difference between the Gross enrolment ratio (%) in Primary schools in 2002 and the Gross enrolment ratio (%) in Tertiary schools in 2004?
Keep it short and to the point. 84.69. What is the difference between the Gross enrolment ratio (%) in Secondary schools in 2002 and the Gross enrolment ratio (%) in Tertiary schools in 2004?
Your answer should be compact. 74.2. What is the difference between the Gross enrolment ratio (%) of Pre-primary schools in 2002 and the Gross enrolment ratio (%) of Primary schools in 2005?
Give a very brief answer. -12.91. What is the difference between the Gross enrolment ratio (%) of Pre-primary schools in 2002 and the Gross enrolment ratio (%) of Secondary schools in 2005?
Your answer should be very brief. 2.54. What is the difference between the Gross enrolment ratio (%) in Pre-primary schools in 2002 and the Gross enrolment ratio (%) in Tertiary schools in 2005?
Ensure brevity in your answer.  66.79. What is the difference between the Gross enrolment ratio (%) of Primary schools in 2002 and the Gross enrolment ratio (%) of Secondary schools in 2005?
Make the answer very short. 15.07. What is the difference between the Gross enrolment ratio (%) in Primary schools in 2002 and the Gross enrolment ratio (%) in Tertiary schools in 2005?
Make the answer very short. 79.31. What is the difference between the Gross enrolment ratio (%) of Secondary schools in 2002 and the Gross enrolment ratio (%) of Tertiary schools in 2005?
Provide a short and direct response. 68.82. What is the difference between the Gross enrolment ratio (%) of Pre-primary schools in 2002 and the Gross enrolment ratio (%) of Primary schools in 2006?
Your response must be concise. -15.77. What is the difference between the Gross enrolment ratio (%) of Pre-primary schools in 2002 and the Gross enrolment ratio (%) of Secondary schools in 2006?
Ensure brevity in your answer.  1.11. What is the difference between the Gross enrolment ratio (%) of Pre-primary schools in 2002 and the Gross enrolment ratio (%) of Tertiary schools in 2006?
Your answer should be compact. 67.57. What is the difference between the Gross enrolment ratio (%) in Primary schools in 2002 and the Gross enrolment ratio (%) in Secondary schools in 2006?
Your answer should be very brief. 13.64. What is the difference between the Gross enrolment ratio (%) in Primary schools in 2002 and the Gross enrolment ratio (%) in Tertiary schools in 2006?
Offer a terse response. 80.1. What is the difference between the Gross enrolment ratio (%) of Secondary schools in 2002 and the Gross enrolment ratio (%) of Tertiary schools in 2006?
Provide a succinct answer. 69.6. What is the difference between the Gross enrolment ratio (%) in Pre-primary schools in 2002 and the Gross enrolment ratio (%) in Primary schools in 2007?
Your answer should be compact. -16.75. What is the difference between the Gross enrolment ratio (%) of Pre-primary schools in 2002 and the Gross enrolment ratio (%) of Secondary schools in 2007?
Ensure brevity in your answer.  -4.08. What is the difference between the Gross enrolment ratio (%) of Pre-primary schools in 2002 and the Gross enrolment ratio (%) of Tertiary schools in 2007?
Provide a succinct answer. 64.54. What is the difference between the Gross enrolment ratio (%) of Primary schools in 2002 and the Gross enrolment ratio (%) of Secondary schools in 2007?
Keep it short and to the point. 8.45. What is the difference between the Gross enrolment ratio (%) in Primary schools in 2002 and the Gross enrolment ratio (%) in Tertiary schools in 2007?
Keep it short and to the point. 77.07. What is the difference between the Gross enrolment ratio (%) of Secondary schools in 2002 and the Gross enrolment ratio (%) of Tertiary schools in 2007?
Offer a very short reply. 66.58. What is the difference between the Gross enrolment ratio (%) of Pre-primary schools in 2003 and the Gross enrolment ratio (%) of Primary schools in 2004?
Provide a short and direct response. -11.22. What is the difference between the Gross enrolment ratio (%) in Pre-primary schools in 2003 and the Gross enrolment ratio (%) in Secondary schools in 2004?
Offer a terse response. 2.37. What is the difference between the Gross enrolment ratio (%) of Pre-primary schools in 2003 and the Gross enrolment ratio (%) of Tertiary schools in 2004?
Offer a very short reply. 73.32. What is the difference between the Gross enrolment ratio (%) of Primary schools in 2003 and the Gross enrolment ratio (%) of Secondary schools in 2004?
Provide a short and direct response. 11.96. What is the difference between the Gross enrolment ratio (%) of Primary schools in 2003 and the Gross enrolment ratio (%) of Tertiary schools in 2004?
Your answer should be compact. 82.91. What is the difference between the Gross enrolment ratio (%) in Secondary schools in 2003 and the Gross enrolment ratio (%) in Tertiary schools in 2004?
Offer a very short reply. 72.79. What is the difference between the Gross enrolment ratio (%) in Pre-primary schools in 2003 and the Gross enrolment ratio (%) in Primary schools in 2005?
Offer a terse response. -11.75. What is the difference between the Gross enrolment ratio (%) of Pre-primary schools in 2003 and the Gross enrolment ratio (%) of Secondary schools in 2005?
Offer a terse response. 3.69. What is the difference between the Gross enrolment ratio (%) of Pre-primary schools in 2003 and the Gross enrolment ratio (%) of Tertiary schools in 2005?
Make the answer very short. 67.94. What is the difference between the Gross enrolment ratio (%) of Primary schools in 2003 and the Gross enrolment ratio (%) of Secondary schools in 2005?
Give a very brief answer. 13.29. What is the difference between the Gross enrolment ratio (%) in Primary schools in 2003 and the Gross enrolment ratio (%) in Tertiary schools in 2005?
Make the answer very short. 77.53. What is the difference between the Gross enrolment ratio (%) in Secondary schools in 2003 and the Gross enrolment ratio (%) in Tertiary schools in 2005?
Provide a succinct answer. 67.41. What is the difference between the Gross enrolment ratio (%) of Pre-primary schools in 2003 and the Gross enrolment ratio (%) of Primary schools in 2006?
Make the answer very short. -14.62. What is the difference between the Gross enrolment ratio (%) of Pre-primary schools in 2003 and the Gross enrolment ratio (%) of Secondary schools in 2006?
Give a very brief answer. 2.27. What is the difference between the Gross enrolment ratio (%) in Pre-primary schools in 2003 and the Gross enrolment ratio (%) in Tertiary schools in 2006?
Your answer should be very brief. 68.72. What is the difference between the Gross enrolment ratio (%) in Primary schools in 2003 and the Gross enrolment ratio (%) in Secondary schools in 2006?
Provide a succinct answer. 11.86. What is the difference between the Gross enrolment ratio (%) of Primary schools in 2003 and the Gross enrolment ratio (%) of Tertiary schools in 2006?
Offer a terse response. 78.31. What is the difference between the Gross enrolment ratio (%) of Secondary schools in 2003 and the Gross enrolment ratio (%) of Tertiary schools in 2006?
Give a very brief answer. 68.19. What is the difference between the Gross enrolment ratio (%) in Pre-primary schools in 2003 and the Gross enrolment ratio (%) in Primary schools in 2007?
Give a very brief answer. -15.6. What is the difference between the Gross enrolment ratio (%) of Pre-primary schools in 2003 and the Gross enrolment ratio (%) of Secondary schools in 2007?
Give a very brief answer. -2.92. What is the difference between the Gross enrolment ratio (%) of Pre-primary schools in 2003 and the Gross enrolment ratio (%) of Tertiary schools in 2007?
Offer a terse response. 65.7. What is the difference between the Gross enrolment ratio (%) of Primary schools in 2003 and the Gross enrolment ratio (%) of Secondary schools in 2007?
Your response must be concise. 6.67. What is the difference between the Gross enrolment ratio (%) in Primary schools in 2003 and the Gross enrolment ratio (%) in Tertiary schools in 2007?
Ensure brevity in your answer.  75.29. What is the difference between the Gross enrolment ratio (%) of Secondary schools in 2003 and the Gross enrolment ratio (%) of Tertiary schools in 2007?
Ensure brevity in your answer.  65.17. What is the difference between the Gross enrolment ratio (%) of Pre-primary schools in 2004 and the Gross enrolment ratio (%) of Primary schools in 2005?
Provide a short and direct response. -12.6. What is the difference between the Gross enrolment ratio (%) of Pre-primary schools in 2004 and the Gross enrolment ratio (%) of Secondary schools in 2005?
Offer a terse response. 2.85. What is the difference between the Gross enrolment ratio (%) of Pre-primary schools in 2004 and the Gross enrolment ratio (%) of Tertiary schools in 2005?
Offer a very short reply. 67.1. What is the difference between the Gross enrolment ratio (%) of Primary schools in 2004 and the Gross enrolment ratio (%) of Secondary schools in 2005?
Offer a very short reply. 14.91. What is the difference between the Gross enrolment ratio (%) of Primary schools in 2004 and the Gross enrolment ratio (%) of Tertiary schools in 2005?
Your answer should be very brief. 79.16. What is the difference between the Gross enrolment ratio (%) in Secondary schools in 2004 and the Gross enrolment ratio (%) in Tertiary schools in 2005?
Offer a very short reply. 65.57. What is the difference between the Gross enrolment ratio (%) in Pre-primary schools in 2004 and the Gross enrolment ratio (%) in Primary schools in 2006?
Your answer should be compact. -15.46. What is the difference between the Gross enrolment ratio (%) of Pre-primary schools in 2004 and the Gross enrolment ratio (%) of Secondary schools in 2006?
Ensure brevity in your answer.  1.42. What is the difference between the Gross enrolment ratio (%) in Pre-primary schools in 2004 and the Gross enrolment ratio (%) in Tertiary schools in 2006?
Provide a succinct answer. 67.88. What is the difference between the Gross enrolment ratio (%) of Primary schools in 2004 and the Gross enrolment ratio (%) of Secondary schools in 2006?
Make the answer very short. 13.48. What is the difference between the Gross enrolment ratio (%) of Primary schools in 2004 and the Gross enrolment ratio (%) of Tertiary schools in 2006?
Offer a terse response. 79.94. What is the difference between the Gross enrolment ratio (%) in Secondary schools in 2004 and the Gross enrolment ratio (%) in Tertiary schools in 2006?
Provide a succinct answer. 66.35. What is the difference between the Gross enrolment ratio (%) of Pre-primary schools in 2004 and the Gross enrolment ratio (%) of Primary schools in 2007?
Make the answer very short. -16.44. What is the difference between the Gross enrolment ratio (%) in Pre-primary schools in 2004 and the Gross enrolment ratio (%) in Secondary schools in 2007?
Your answer should be very brief. -3.77. What is the difference between the Gross enrolment ratio (%) of Pre-primary schools in 2004 and the Gross enrolment ratio (%) of Tertiary schools in 2007?
Keep it short and to the point. 64.85. What is the difference between the Gross enrolment ratio (%) of Primary schools in 2004 and the Gross enrolment ratio (%) of Secondary schools in 2007?
Ensure brevity in your answer.  8.29. What is the difference between the Gross enrolment ratio (%) of Primary schools in 2004 and the Gross enrolment ratio (%) of Tertiary schools in 2007?
Your answer should be compact. 76.91. What is the difference between the Gross enrolment ratio (%) in Secondary schools in 2004 and the Gross enrolment ratio (%) in Tertiary schools in 2007?
Provide a succinct answer. 63.33. What is the difference between the Gross enrolment ratio (%) in Pre-primary schools in 2005 and the Gross enrolment ratio (%) in Primary schools in 2006?
Your answer should be compact. -13.81. What is the difference between the Gross enrolment ratio (%) of Pre-primary schools in 2005 and the Gross enrolment ratio (%) of Secondary schools in 2006?
Keep it short and to the point. 3.07. What is the difference between the Gross enrolment ratio (%) in Pre-primary schools in 2005 and the Gross enrolment ratio (%) in Tertiary schools in 2006?
Keep it short and to the point. 69.52. What is the difference between the Gross enrolment ratio (%) of Primary schools in 2005 and the Gross enrolment ratio (%) of Secondary schools in 2006?
Give a very brief answer. 14.02. What is the difference between the Gross enrolment ratio (%) in Primary schools in 2005 and the Gross enrolment ratio (%) in Tertiary schools in 2006?
Make the answer very short. 80.47. What is the difference between the Gross enrolment ratio (%) of Secondary schools in 2005 and the Gross enrolment ratio (%) of Tertiary schools in 2006?
Your response must be concise. 65.03. What is the difference between the Gross enrolment ratio (%) in Pre-primary schools in 2005 and the Gross enrolment ratio (%) in Primary schools in 2007?
Offer a terse response. -14.8. What is the difference between the Gross enrolment ratio (%) of Pre-primary schools in 2005 and the Gross enrolment ratio (%) of Secondary schools in 2007?
Offer a terse response. -2.12. What is the difference between the Gross enrolment ratio (%) in Pre-primary schools in 2005 and the Gross enrolment ratio (%) in Tertiary schools in 2007?
Provide a short and direct response. 66.5. What is the difference between the Gross enrolment ratio (%) of Primary schools in 2005 and the Gross enrolment ratio (%) of Secondary schools in 2007?
Provide a short and direct response. 8.83. What is the difference between the Gross enrolment ratio (%) of Primary schools in 2005 and the Gross enrolment ratio (%) of Tertiary schools in 2007?
Give a very brief answer. 77.45. What is the difference between the Gross enrolment ratio (%) in Secondary schools in 2005 and the Gross enrolment ratio (%) in Tertiary schools in 2007?
Keep it short and to the point. 62. What is the difference between the Gross enrolment ratio (%) of Pre-primary schools in 2006 and the Gross enrolment ratio (%) of Primary schools in 2007?
Offer a terse response. -6.2. What is the difference between the Gross enrolment ratio (%) of Pre-primary schools in 2006 and the Gross enrolment ratio (%) of Secondary schools in 2007?
Ensure brevity in your answer.  6.47. What is the difference between the Gross enrolment ratio (%) of Pre-primary schools in 2006 and the Gross enrolment ratio (%) of Tertiary schools in 2007?
Offer a terse response. 75.1. What is the difference between the Gross enrolment ratio (%) of Primary schools in 2006 and the Gross enrolment ratio (%) of Secondary schools in 2007?
Provide a short and direct response. 11.69. What is the difference between the Gross enrolment ratio (%) in Primary schools in 2006 and the Gross enrolment ratio (%) in Tertiary schools in 2007?
Your answer should be very brief. 80.31. What is the difference between the Gross enrolment ratio (%) of Secondary schools in 2006 and the Gross enrolment ratio (%) of Tertiary schools in 2007?
Ensure brevity in your answer.  63.43. What is the average Gross enrolment ratio (%) in Pre-primary schools per year?
Give a very brief answer. 100.16. What is the average Gross enrolment ratio (%) of Primary schools per year?
Your answer should be compact. 111.59. What is the average Gross enrolment ratio (%) of Secondary schools per year?
Offer a very short reply. 98.44. What is the average Gross enrolment ratio (%) in Tertiary schools per year?
Provide a short and direct response. 29.23. In the year 1999, what is the difference between the Gross enrolment ratio (%) of Pre-primary schools and Gross enrolment ratio (%) of Primary schools?
Ensure brevity in your answer.  -17.87. In the year 1999, what is the difference between the Gross enrolment ratio (%) of Pre-primary schools and Gross enrolment ratio (%) of Secondary schools?
Make the answer very short. -4.47. In the year 1999, what is the difference between the Gross enrolment ratio (%) of Pre-primary schools and Gross enrolment ratio (%) of Tertiary schools?
Keep it short and to the point. 66.26. In the year 1999, what is the difference between the Gross enrolment ratio (%) in Primary schools and Gross enrolment ratio (%) in Secondary schools?
Provide a short and direct response. 13.4. In the year 1999, what is the difference between the Gross enrolment ratio (%) of Primary schools and Gross enrolment ratio (%) of Tertiary schools?
Make the answer very short. 84.13. In the year 1999, what is the difference between the Gross enrolment ratio (%) in Secondary schools and Gross enrolment ratio (%) in Tertiary schools?
Offer a terse response. 70.73. In the year 2000, what is the difference between the Gross enrolment ratio (%) of Pre-primary schools and Gross enrolment ratio (%) of Primary schools?
Provide a succinct answer. -14.9. In the year 2000, what is the difference between the Gross enrolment ratio (%) of Pre-primary schools and Gross enrolment ratio (%) of Secondary schools?
Provide a short and direct response. -0.58. In the year 2000, what is the difference between the Gross enrolment ratio (%) in Pre-primary schools and Gross enrolment ratio (%) in Tertiary schools?
Provide a short and direct response. 66.25. In the year 2000, what is the difference between the Gross enrolment ratio (%) in Primary schools and Gross enrolment ratio (%) in Secondary schools?
Make the answer very short. 14.32. In the year 2000, what is the difference between the Gross enrolment ratio (%) of Primary schools and Gross enrolment ratio (%) of Tertiary schools?
Provide a short and direct response. 81.15. In the year 2000, what is the difference between the Gross enrolment ratio (%) in Secondary schools and Gross enrolment ratio (%) in Tertiary schools?
Your answer should be very brief. 66.83. In the year 2001, what is the difference between the Gross enrolment ratio (%) of Pre-primary schools and Gross enrolment ratio (%) of Primary schools?
Your response must be concise. -11.82. In the year 2001, what is the difference between the Gross enrolment ratio (%) of Pre-primary schools and Gross enrolment ratio (%) of Secondary schools?
Your answer should be compact. -0.4. In the year 2001, what is the difference between the Gross enrolment ratio (%) of Pre-primary schools and Gross enrolment ratio (%) of Tertiary schools?
Provide a succinct answer. 68.53. In the year 2001, what is the difference between the Gross enrolment ratio (%) of Primary schools and Gross enrolment ratio (%) of Secondary schools?
Your answer should be very brief. 11.42. In the year 2001, what is the difference between the Gross enrolment ratio (%) in Primary schools and Gross enrolment ratio (%) in Tertiary schools?
Offer a terse response. 80.35. In the year 2001, what is the difference between the Gross enrolment ratio (%) in Secondary schools and Gross enrolment ratio (%) in Tertiary schools?
Offer a very short reply. 68.93. In the year 2002, what is the difference between the Gross enrolment ratio (%) of Pre-primary schools and Gross enrolment ratio (%) of Primary schools?
Your answer should be very brief. -12.53. In the year 2002, what is the difference between the Gross enrolment ratio (%) in Pre-primary schools and Gross enrolment ratio (%) in Secondary schools?
Your response must be concise. -2.04. In the year 2002, what is the difference between the Gross enrolment ratio (%) of Pre-primary schools and Gross enrolment ratio (%) of Tertiary schools?
Keep it short and to the point. 71.77. In the year 2002, what is the difference between the Gross enrolment ratio (%) of Primary schools and Gross enrolment ratio (%) of Secondary schools?
Make the answer very short. 10.49. In the year 2002, what is the difference between the Gross enrolment ratio (%) of Primary schools and Gross enrolment ratio (%) of Tertiary schools?
Make the answer very short. 84.3. In the year 2002, what is the difference between the Gross enrolment ratio (%) of Secondary schools and Gross enrolment ratio (%) of Tertiary schools?
Offer a terse response. 73.81. In the year 2003, what is the difference between the Gross enrolment ratio (%) of Pre-primary schools and Gross enrolment ratio (%) of Primary schools?
Offer a terse response. -9.59. In the year 2003, what is the difference between the Gross enrolment ratio (%) of Pre-primary schools and Gross enrolment ratio (%) of Secondary schools?
Give a very brief answer. 0.53. In the year 2003, what is the difference between the Gross enrolment ratio (%) of Pre-primary schools and Gross enrolment ratio (%) of Tertiary schools?
Keep it short and to the point. 72.87. In the year 2003, what is the difference between the Gross enrolment ratio (%) in Primary schools and Gross enrolment ratio (%) in Secondary schools?
Provide a short and direct response. 10.12. In the year 2003, what is the difference between the Gross enrolment ratio (%) in Primary schools and Gross enrolment ratio (%) in Tertiary schools?
Provide a short and direct response. 82.46. In the year 2003, what is the difference between the Gross enrolment ratio (%) of Secondary schools and Gross enrolment ratio (%) of Tertiary schools?
Keep it short and to the point. 72.33. In the year 2004, what is the difference between the Gross enrolment ratio (%) of Pre-primary schools and Gross enrolment ratio (%) of Primary schools?
Your response must be concise. -12.06. In the year 2004, what is the difference between the Gross enrolment ratio (%) in Pre-primary schools and Gross enrolment ratio (%) in Secondary schools?
Provide a short and direct response. 1.53. In the year 2004, what is the difference between the Gross enrolment ratio (%) in Pre-primary schools and Gross enrolment ratio (%) in Tertiary schools?
Your response must be concise. 72.48. In the year 2004, what is the difference between the Gross enrolment ratio (%) in Primary schools and Gross enrolment ratio (%) in Secondary schools?
Your answer should be compact. 13.59. In the year 2004, what is the difference between the Gross enrolment ratio (%) in Primary schools and Gross enrolment ratio (%) in Tertiary schools?
Offer a terse response. 84.53. In the year 2004, what is the difference between the Gross enrolment ratio (%) of Secondary schools and Gross enrolment ratio (%) of Tertiary schools?
Provide a short and direct response. 70.95. In the year 2005, what is the difference between the Gross enrolment ratio (%) in Pre-primary schools and Gross enrolment ratio (%) in Primary schools?
Make the answer very short. -10.95. In the year 2005, what is the difference between the Gross enrolment ratio (%) of Pre-primary schools and Gross enrolment ratio (%) of Secondary schools?
Make the answer very short. 4.5. In the year 2005, what is the difference between the Gross enrolment ratio (%) of Pre-primary schools and Gross enrolment ratio (%) of Tertiary schools?
Offer a very short reply. 68.74. In the year 2005, what is the difference between the Gross enrolment ratio (%) of Primary schools and Gross enrolment ratio (%) of Secondary schools?
Your response must be concise. 15.45. In the year 2005, what is the difference between the Gross enrolment ratio (%) in Primary schools and Gross enrolment ratio (%) in Tertiary schools?
Your answer should be very brief. 79.69. In the year 2005, what is the difference between the Gross enrolment ratio (%) of Secondary schools and Gross enrolment ratio (%) of Tertiary schools?
Ensure brevity in your answer.  64.25. In the year 2006, what is the difference between the Gross enrolment ratio (%) in Pre-primary schools and Gross enrolment ratio (%) in Primary schools?
Provide a short and direct response. -5.22. In the year 2006, what is the difference between the Gross enrolment ratio (%) in Pre-primary schools and Gross enrolment ratio (%) in Secondary schools?
Your answer should be very brief. 11.66. In the year 2006, what is the difference between the Gross enrolment ratio (%) of Pre-primary schools and Gross enrolment ratio (%) of Tertiary schools?
Ensure brevity in your answer.  78.12. In the year 2006, what is the difference between the Gross enrolment ratio (%) of Primary schools and Gross enrolment ratio (%) of Secondary schools?
Provide a succinct answer. 16.88. In the year 2006, what is the difference between the Gross enrolment ratio (%) of Primary schools and Gross enrolment ratio (%) of Tertiary schools?
Your response must be concise. 83.34. In the year 2006, what is the difference between the Gross enrolment ratio (%) of Secondary schools and Gross enrolment ratio (%) of Tertiary schools?
Give a very brief answer. 66.45. In the year 2007, what is the difference between the Gross enrolment ratio (%) of Pre-primary schools and Gross enrolment ratio (%) of Primary schools?
Provide a short and direct response. -7.93. In the year 2007, what is the difference between the Gross enrolment ratio (%) of Pre-primary schools and Gross enrolment ratio (%) of Secondary schools?
Your answer should be very brief. 4.74. In the year 2007, what is the difference between the Gross enrolment ratio (%) of Pre-primary schools and Gross enrolment ratio (%) of Tertiary schools?
Your answer should be very brief. 73.36. In the year 2007, what is the difference between the Gross enrolment ratio (%) in Primary schools and Gross enrolment ratio (%) in Secondary schools?
Your response must be concise. 12.68. In the year 2007, what is the difference between the Gross enrolment ratio (%) of Primary schools and Gross enrolment ratio (%) of Tertiary schools?
Ensure brevity in your answer.  81.3. In the year 2007, what is the difference between the Gross enrolment ratio (%) in Secondary schools and Gross enrolment ratio (%) in Tertiary schools?
Your answer should be very brief. 68.62. What is the ratio of the Gross enrolment ratio (%) of Pre-primary schools in 1999 to that in 2000?
Make the answer very short. 0.98. What is the ratio of the Gross enrolment ratio (%) of Primary schools in 1999 to that in 2000?
Offer a terse response. 1.01. What is the ratio of the Gross enrolment ratio (%) of Tertiary schools in 1999 to that in 2000?
Make the answer very short. 0.95. What is the ratio of the Gross enrolment ratio (%) of Pre-primary schools in 1999 to that in 2001?
Your answer should be very brief. 0.97. What is the ratio of the Gross enrolment ratio (%) in Primary schools in 1999 to that in 2001?
Provide a short and direct response. 1.03. What is the ratio of the Gross enrolment ratio (%) of Secondary schools in 1999 to that in 2001?
Provide a short and direct response. 1.01. What is the ratio of the Gross enrolment ratio (%) in Pre-primary schools in 1999 to that in 2002?
Provide a short and direct response. 0.96. What is the ratio of the Gross enrolment ratio (%) in Primary schools in 1999 to that in 2002?
Keep it short and to the point. 1.01. What is the ratio of the Gross enrolment ratio (%) of Tertiary schools in 1999 to that in 2002?
Your answer should be compact. 1.05. What is the ratio of the Gross enrolment ratio (%) in Pre-primary schools in 1999 to that in 2003?
Your response must be concise. 0.95. What is the ratio of the Gross enrolment ratio (%) of Primary schools in 1999 to that in 2003?
Provide a short and direct response. 1.03. What is the ratio of the Gross enrolment ratio (%) of Tertiary schools in 1999 to that in 2003?
Provide a short and direct response. 1.05. What is the ratio of the Gross enrolment ratio (%) in Pre-primary schools in 1999 to that in 2004?
Your answer should be very brief. 0.95. What is the ratio of the Gross enrolment ratio (%) in Primary schools in 1999 to that in 2004?
Offer a terse response. 1.01. What is the ratio of the Gross enrolment ratio (%) of Secondary schools in 1999 to that in 2004?
Offer a terse response. 1.02. What is the ratio of the Gross enrolment ratio (%) in Tertiary schools in 1999 to that in 2004?
Offer a terse response. 1.07. What is the ratio of the Gross enrolment ratio (%) of Pre-primary schools in 1999 to that in 2005?
Offer a very short reply. 0.94. What is the ratio of the Gross enrolment ratio (%) of Primary schools in 1999 to that in 2005?
Offer a very short reply. 1.01. What is the ratio of the Gross enrolment ratio (%) in Secondary schools in 1999 to that in 2005?
Provide a short and direct response. 1.03. What is the ratio of the Gross enrolment ratio (%) in Tertiary schools in 1999 to that in 2005?
Your answer should be very brief. 0.89. What is the ratio of the Gross enrolment ratio (%) in Pre-primary schools in 1999 to that in 2006?
Make the answer very short. 0.87. What is the ratio of the Gross enrolment ratio (%) of Primary schools in 1999 to that in 2006?
Ensure brevity in your answer.  0.98. What is the ratio of the Gross enrolment ratio (%) of Secondary schools in 1999 to that in 2006?
Your answer should be very brief. 1.01. What is the ratio of the Gross enrolment ratio (%) in Tertiary schools in 1999 to that in 2006?
Offer a very short reply. 0.91. What is the ratio of the Gross enrolment ratio (%) of Pre-primary schools in 1999 to that in 2007?
Your answer should be compact. 0.88. What is the ratio of the Gross enrolment ratio (%) in Primary schools in 1999 to that in 2007?
Give a very brief answer. 0.97. What is the ratio of the Gross enrolment ratio (%) in Secondary schools in 1999 to that in 2007?
Offer a very short reply. 0.96. What is the ratio of the Gross enrolment ratio (%) of Tertiary schools in 1999 to that in 2007?
Your answer should be compact. 0.83. What is the ratio of the Gross enrolment ratio (%) in Pre-primary schools in 2000 to that in 2001?
Keep it short and to the point. 0.98. What is the ratio of the Gross enrolment ratio (%) of Primary schools in 2000 to that in 2001?
Your response must be concise. 1.01. What is the ratio of the Gross enrolment ratio (%) of Secondary schools in 2000 to that in 2001?
Provide a short and direct response. 0.98. What is the ratio of the Gross enrolment ratio (%) in Tertiary schools in 2000 to that in 2001?
Your answer should be compact. 1.02. What is the ratio of the Gross enrolment ratio (%) of Pre-primary schools in 2000 to that in 2002?
Offer a very short reply. 0.97. What is the ratio of the Gross enrolment ratio (%) in Secondary schools in 2000 to that in 2002?
Provide a short and direct response. 0.96. What is the ratio of the Gross enrolment ratio (%) in Tertiary schools in 2000 to that in 2002?
Offer a terse response. 1.11. What is the ratio of the Gross enrolment ratio (%) of Pre-primary schools in 2000 to that in 2003?
Your response must be concise. 0.96. What is the ratio of the Gross enrolment ratio (%) in Primary schools in 2000 to that in 2003?
Your response must be concise. 1.01. What is the ratio of the Gross enrolment ratio (%) of Secondary schools in 2000 to that in 2003?
Your response must be concise. 0.97. What is the ratio of the Gross enrolment ratio (%) in Tertiary schools in 2000 to that in 2003?
Provide a succinct answer. 1.11. What is the ratio of the Gross enrolment ratio (%) in Pre-primary schools in 2000 to that in 2004?
Offer a terse response. 0.97. What is the ratio of the Gross enrolment ratio (%) in Tertiary schools in 2000 to that in 2004?
Make the answer very short. 1.13. What is the ratio of the Gross enrolment ratio (%) of Pre-primary schools in 2000 to that in 2005?
Offer a terse response. 0.95. What is the ratio of the Gross enrolment ratio (%) of Primary schools in 2000 to that in 2005?
Provide a short and direct response. 0.99. What is the ratio of the Gross enrolment ratio (%) in Tertiary schools in 2000 to that in 2005?
Give a very brief answer. 0.94. What is the ratio of the Gross enrolment ratio (%) of Pre-primary schools in 2000 to that in 2006?
Provide a succinct answer. 0.88. What is the ratio of the Gross enrolment ratio (%) of Primary schools in 2000 to that in 2006?
Keep it short and to the point. 0.97. What is the ratio of the Gross enrolment ratio (%) of Tertiary schools in 2000 to that in 2006?
Offer a very short reply. 0.96. What is the ratio of the Gross enrolment ratio (%) of Pre-primary schools in 2000 to that in 2007?
Your response must be concise. 0.89. What is the ratio of the Gross enrolment ratio (%) of Primary schools in 2000 to that in 2007?
Provide a short and direct response. 0.96. What is the ratio of the Gross enrolment ratio (%) of Secondary schools in 2000 to that in 2007?
Offer a very short reply. 0.94. What is the ratio of the Gross enrolment ratio (%) in Tertiary schools in 2000 to that in 2007?
Ensure brevity in your answer.  0.87. What is the ratio of the Gross enrolment ratio (%) in Pre-primary schools in 2001 to that in 2002?
Offer a terse response. 0.99. What is the ratio of the Gross enrolment ratio (%) of Primary schools in 2001 to that in 2002?
Provide a short and direct response. 0.99. What is the ratio of the Gross enrolment ratio (%) in Secondary schools in 2001 to that in 2002?
Your answer should be very brief. 0.97. What is the ratio of the Gross enrolment ratio (%) of Tertiary schools in 2001 to that in 2002?
Give a very brief answer. 1.09. What is the ratio of the Gross enrolment ratio (%) in Pre-primary schools in 2001 to that in 2003?
Your answer should be compact. 0.98. What is the ratio of the Gross enrolment ratio (%) of Primary schools in 2001 to that in 2003?
Make the answer very short. 1. What is the ratio of the Gross enrolment ratio (%) in Secondary schools in 2001 to that in 2003?
Keep it short and to the point. 0.99. What is the ratio of the Gross enrolment ratio (%) in Tertiary schools in 2001 to that in 2003?
Give a very brief answer. 1.09. What is the ratio of the Gross enrolment ratio (%) of Pre-primary schools in 2001 to that in 2004?
Keep it short and to the point. 0.99. What is the ratio of the Gross enrolment ratio (%) of Primary schools in 2001 to that in 2004?
Offer a very short reply. 0.99. What is the ratio of the Gross enrolment ratio (%) of Secondary schools in 2001 to that in 2004?
Ensure brevity in your answer.  1.01. What is the ratio of the Gross enrolment ratio (%) of Tertiary schools in 2001 to that in 2004?
Ensure brevity in your answer.  1.1. What is the ratio of the Gross enrolment ratio (%) of Pre-primary schools in 2001 to that in 2005?
Your response must be concise. 0.97. What is the ratio of the Gross enrolment ratio (%) of Primary schools in 2001 to that in 2005?
Provide a succinct answer. 0.98. What is the ratio of the Gross enrolment ratio (%) in Secondary schools in 2001 to that in 2005?
Your response must be concise. 1.02. What is the ratio of the Gross enrolment ratio (%) in Tertiary schools in 2001 to that in 2005?
Give a very brief answer. 0.92. What is the ratio of the Gross enrolment ratio (%) in Pre-primary schools in 2001 to that in 2006?
Ensure brevity in your answer.  0.9. What is the ratio of the Gross enrolment ratio (%) in Primary schools in 2001 to that in 2006?
Your answer should be very brief. 0.96. What is the ratio of the Gross enrolment ratio (%) in Tertiary schools in 2001 to that in 2006?
Your response must be concise. 0.94. What is the ratio of the Gross enrolment ratio (%) in Pre-primary schools in 2001 to that in 2007?
Your answer should be compact. 0.91. What is the ratio of the Gross enrolment ratio (%) of Primary schools in 2001 to that in 2007?
Keep it short and to the point. 0.95. What is the ratio of the Gross enrolment ratio (%) in Secondary schools in 2001 to that in 2007?
Offer a terse response. 0.96. What is the ratio of the Gross enrolment ratio (%) of Tertiary schools in 2001 to that in 2007?
Your response must be concise. 0.86. What is the ratio of the Gross enrolment ratio (%) in Pre-primary schools in 2002 to that in 2003?
Provide a short and direct response. 0.99. What is the ratio of the Gross enrolment ratio (%) in Primary schools in 2002 to that in 2003?
Keep it short and to the point. 1.02. What is the ratio of the Gross enrolment ratio (%) in Secondary schools in 2002 to that in 2003?
Provide a short and direct response. 1.01. What is the ratio of the Gross enrolment ratio (%) of Pre-primary schools in 2002 to that in 2004?
Provide a short and direct response. 1. What is the ratio of the Gross enrolment ratio (%) of Primary schools in 2002 to that in 2004?
Offer a terse response. 1. What is the ratio of the Gross enrolment ratio (%) in Secondary schools in 2002 to that in 2004?
Keep it short and to the point. 1.03. What is the ratio of the Gross enrolment ratio (%) in Tertiary schools in 2002 to that in 2004?
Offer a terse response. 1.01. What is the ratio of the Gross enrolment ratio (%) in Pre-primary schools in 2002 to that in 2005?
Offer a very short reply. 0.98. What is the ratio of the Gross enrolment ratio (%) in Primary schools in 2002 to that in 2005?
Your answer should be very brief. 1. What is the ratio of the Gross enrolment ratio (%) in Secondary schools in 2002 to that in 2005?
Make the answer very short. 1.05. What is the ratio of the Gross enrolment ratio (%) of Tertiary schools in 2002 to that in 2005?
Make the answer very short. 0.84. What is the ratio of the Gross enrolment ratio (%) of Pre-primary schools in 2002 to that in 2006?
Your answer should be very brief. 0.9. What is the ratio of the Gross enrolment ratio (%) of Primary schools in 2002 to that in 2006?
Offer a terse response. 0.97. What is the ratio of the Gross enrolment ratio (%) in Secondary schools in 2002 to that in 2006?
Offer a very short reply. 1.03. What is the ratio of the Gross enrolment ratio (%) in Tertiary schools in 2002 to that in 2006?
Make the answer very short. 0.86. What is the ratio of the Gross enrolment ratio (%) of Pre-primary schools in 2002 to that in 2007?
Give a very brief answer. 0.92. What is the ratio of the Gross enrolment ratio (%) in Primary schools in 2002 to that in 2007?
Make the answer very short. 0.96. What is the ratio of the Gross enrolment ratio (%) of Secondary schools in 2002 to that in 2007?
Offer a very short reply. 0.98. What is the ratio of the Gross enrolment ratio (%) of Tertiary schools in 2002 to that in 2007?
Provide a short and direct response. 0.79. What is the ratio of the Gross enrolment ratio (%) of Pre-primary schools in 2003 to that in 2004?
Ensure brevity in your answer.  1.01. What is the ratio of the Gross enrolment ratio (%) of Secondary schools in 2003 to that in 2004?
Offer a very short reply. 1.02. What is the ratio of the Gross enrolment ratio (%) of Tertiary schools in 2003 to that in 2004?
Keep it short and to the point. 1.02. What is the ratio of the Gross enrolment ratio (%) of Pre-primary schools in 2003 to that in 2005?
Provide a short and direct response. 0.99. What is the ratio of the Gross enrolment ratio (%) of Primary schools in 2003 to that in 2005?
Ensure brevity in your answer.  0.98. What is the ratio of the Gross enrolment ratio (%) in Secondary schools in 2003 to that in 2005?
Ensure brevity in your answer.  1.03. What is the ratio of the Gross enrolment ratio (%) in Tertiary schools in 2003 to that in 2005?
Your response must be concise. 0.84. What is the ratio of the Gross enrolment ratio (%) in Pre-primary schools in 2003 to that in 2006?
Provide a short and direct response. 0.91. What is the ratio of the Gross enrolment ratio (%) in Primary schools in 2003 to that in 2006?
Offer a very short reply. 0.96. What is the ratio of the Gross enrolment ratio (%) of Secondary schools in 2003 to that in 2006?
Your answer should be very brief. 1.02. What is the ratio of the Gross enrolment ratio (%) of Tertiary schools in 2003 to that in 2006?
Make the answer very short. 0.87. What is the ratio of the Gross enrolment ratio (%) of Pre-primary schools in 2003 to that in 2007?
Ensure brevity in your answer.  0.93. What is the ratio of the Gross enrolment ratio (%) in Primary schools in 2003 to that in 2007?
Your answer should be very brief. 0.95. What is the ratio of the Gross enrolment ratio (%) in Secondary schools in 2003 to that in 2007?
Make the answer very short. 0.97. What is the ratio of the Gross enrolment ratio (%) of Tertiary schools in 2003 to that in 2007?
Keep it short and to the point. 0.79. What is the ratio of the Gross enrolment ratio (%) of Pre-primary schools in 2004 to that in 2005?
Ensure brevity in your answer.  0.98. What is the ratio of the Gross enrolment ratio (%) of Secondary schools in 2004 to that in 2005?
Provide a short and direct response. 1.01. What is the ratio of the Gross enrolment ratio (%) of Tertiary schools in 2004 to that in 2005?
Offer a very short reply. 0.83. What is the ratio of the Gross enrolment ratio (%) of Pre-primary schools in 2004 to that in 2006?
Your response must be concise. 0.91. What is the ratio of the Gross enrolment ratio (%) of Primary schools in 2004 to that in 2006?
Offer a very short reply. 0.97. What is the ratio of the Gross enrolment ratio (%) of Secondary schools in 2004 to that in 2006?
Offer a terse response. 1. What is the ratio of the Gross enrolment ratio (%) of Tertiary schools in 2004 to that in 2006?
Your response must be concise. 0.85. What is the ratio of the Gross enrolment ratio (%) of Pre-primary schools in 2004 to that in 2007?
Provide a succinct answer. 0.92. What is the ratio of the Gross enrolment ratio (%) of Primary schools in 2004 to that in 2007?
Provide a succinct answer. 0.96. What is the ratio of the Gross enrolment ratio (%) of Secondary schools in 2004 to that in 2007?
Give a very brief answer. 0.95. What is the ratio of the Gross enrolment ratio (%) in Tertiary schools in 2004 to that in 2007?
Your response must be concise. 0.78. What is the ratio of the Gross enrolment ratio (%) in Pre-primary schools in 2005 to that in 2006?
Provide a short and direct response. 0.92. What is the ratio of the Gross enrolment ratio (%) in Primary schools in 2005 to that in 2006?
Give a very brief answer. 0.97. What is the ratio of the Gross enrolment ratio (%) in Secondary schools in 2005 to that in 2006?
Provide a short and direct response. 0.99. What is the ratio of the Gross enrolment ratio (%) in Tertiary schools in 2005 to that in 2006?
Your answer should be compact. 1.03. What is the ratio of the Gross enrolment ratio (%) of Pre-primary schools in 2005 to that in 2007?
Offer a terse response. 0.94. What is the ratio of the Gross enrolment ratio (%) of Primary schools in 2005 to that in 2007?
Your answer should be very brief. 0.97. What is the ratio of the Gross enrolment ratio (%) in Secondary schools in 2005 to that in 2007?
Provide a succinct answer. 0.94. What is the ratio of the Gross enrolment ratio (%) of Tertiary schools in 2005 to that in 2007?
Your answer should be compact. 0.93. What is the ratio of the Gross enrolment ratio (%) of Pre-primary schools in 2006 to that in 2007?
Your answer should be compact. 1.02. What is the ratio of the Gross enrolment ratio (%) in Secondary schools in 2006 to that in 2007?
Offer a terse response. 0.95. What is the ratio of the Gross enrolment ratio (%) of Tertiary schools in 2006 to that in 2007?
Your response must be concise. 0.91. What is the difference between the highest and the second highest Gross enrolment ratio (%) in Pre-primary schools?
Your response must be concise. 1.73. What is the difference between the highest and the second highest Gross enrolment ratio (%) of Primary schools?
Your answer should be compact. 0.99. What is the difference between the highest and the second highest Gross enrolment ratio (%) of Secondary schools?
Offer a terse response. 2.04. What is the difference between the highest and the second highest Gross enrolment ratio (%) of Tertiary schools?
Your answer should be very brief. 2.24. What is the difference between the highest and the lowest Gross enrolment ratio (%) of Pre-primary schools?
Offer a very short reply. 14.69. What is the difference between the highest and the lowest Gross enrolment ratio (%) of Primary schools?
Your answer should be compact. 6.01. What is the difference between the highest and the lowest Gross enrolment ratio (%) of Secondary schools?
Your answer should be compact. 6.62. What is the difference between the highest and the lowest Gross enrolment ratio (%) of Tertiary schools?
Offer a very short reply. 7.62. 